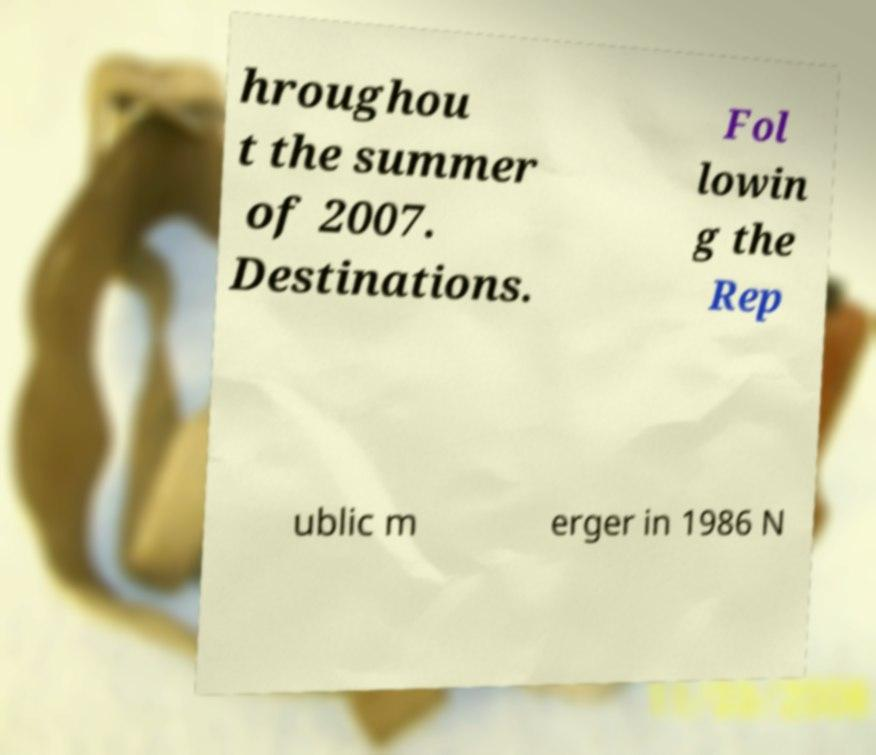Could you assist in decoding the text presented in this image and type it out clearly? hroughou t the summer of 2007. Destinations. Fol lowin g the Rep ublic m erger in 1986 N 